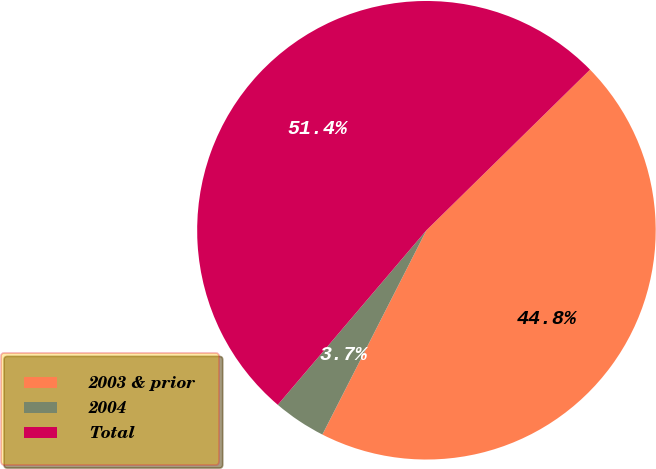<chart> <loc_0><loc_0><loc_500><loc_500><pie_chart><fcel>2003 & prior<fcel>2004<fcel>Total<nl><fcel>44.85%<fcel>3.73%<fcel>51.42%<nl></chart> 